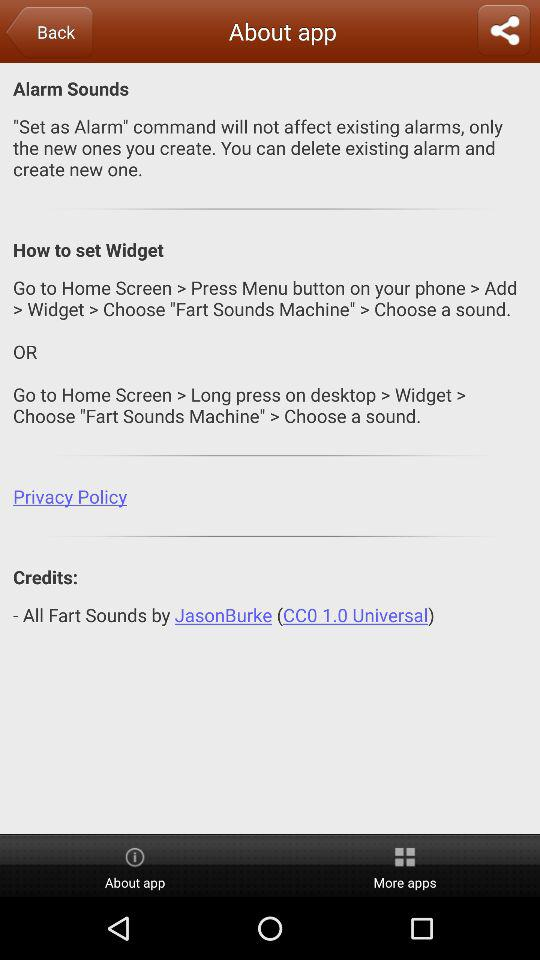Whose contribution is in "All Fart Sounds"? It is by JasonBurke. 